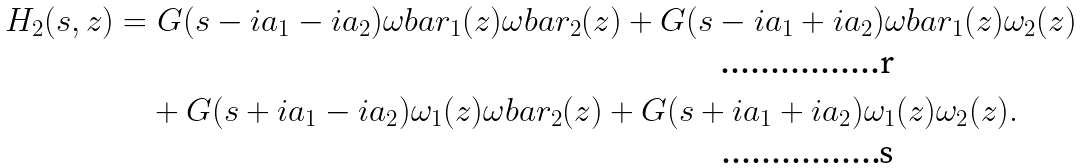<formula> <loc_0><loc_0><loc_500><loc_500>H _ { 2 } ( s , z ) & = G ( s - i a _ { 1 } - i a _ { 2 } ) \omega b a r _ { 1 } ( z ) \omega b a r _ { 2 } ( z ) + G ( s - i a _ { 1 } + i a _ { 2 } ) \omega b a r _ { 1 } ( z ) \omega _ { 2 } ( z ) \\ & \quad + G ( s + i a _ { 1 } - i a _ { 2 } ) \omega _ { 1 } ( z ) \omega b a r _ { 2 } ( z ) + G ( s + i a _ { 1 } + i a _ { 2 } ) \omega _ { 1 } ( z ) \omega _ { 2 } ( z ) .</formula> 